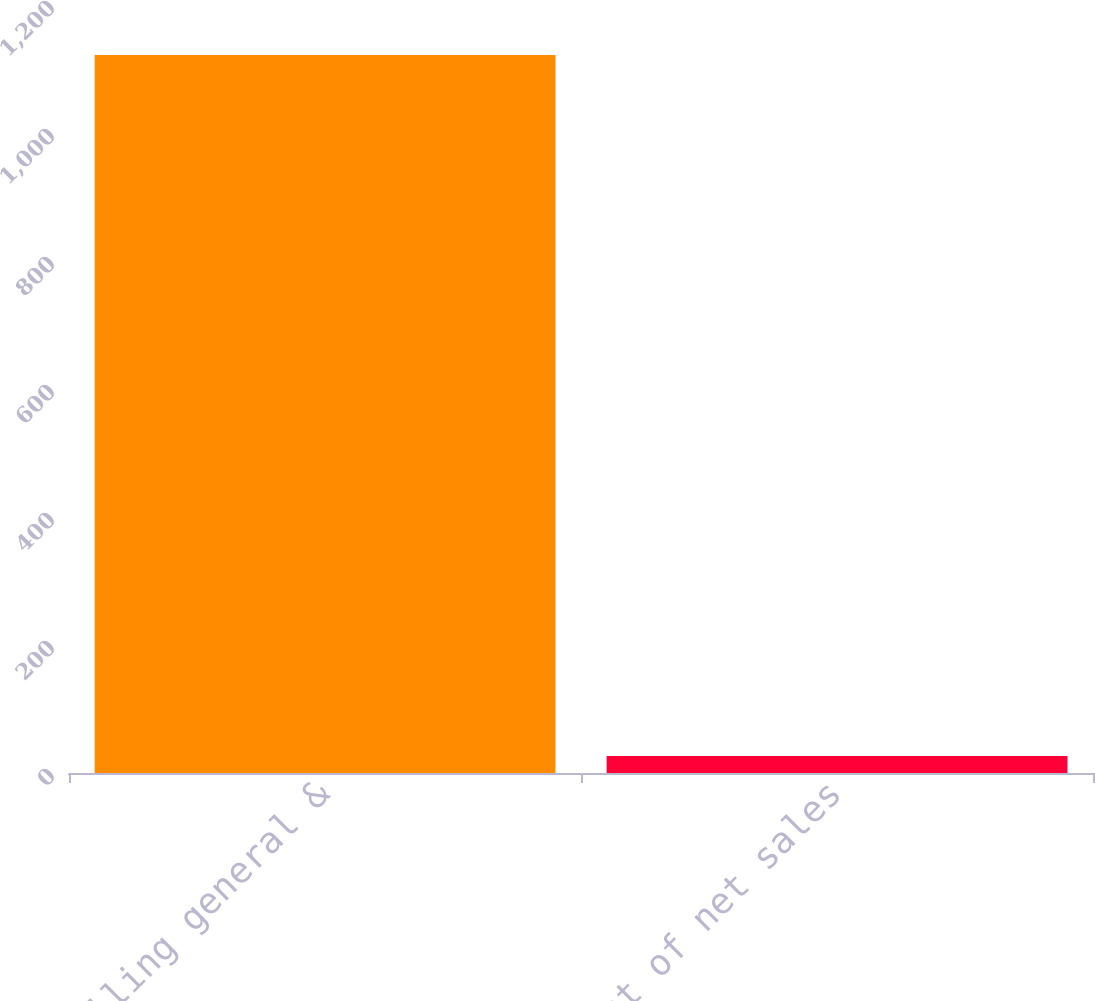<chart> <loc_0><loc_0><loc_500><loc_500><bar_chart><fcel>Selling general &<fcel>Percent of net sales<nl><fcel>1122<fcel>26.5<nl></chart> 